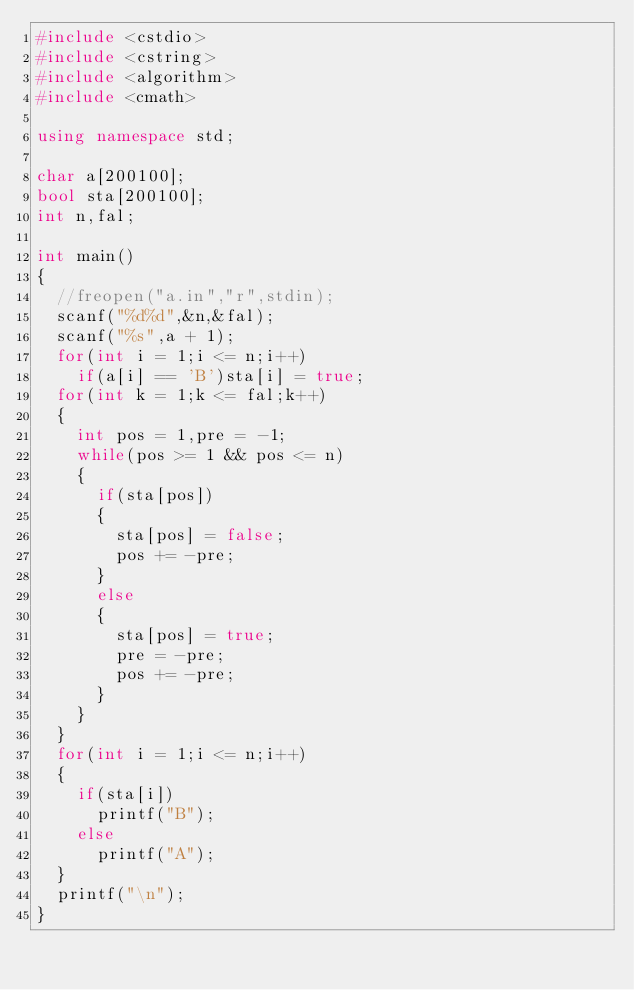Convert code to text. <code><loc_0><loc_0><loc_500><loc_500><_C++_>#include <cstdio>
#include <cstring>
#include <algorithm>
#include <cmath> 

using namespace std;

char a[200100];
bool sta[200100];
int n,fal;

int main()
{
	//freopen("a.in","r",stdin);
	scanf("%d%d",&n,&fal);
	scanf("%s",a + 1);
	for(int i = 1;i <= n;i++)
		if(a[i] == 'B')sta[i] = true;
	for(int k = 1;k <= fal;k++)
	{
		int pos = 1,pre = -1;
		while(pos >= 1 && pos <= n)
		{
			if(sta[pos])
			{
				sta[pos] = false;
				pos += -pre;
			}
			else
			{
				sta[pos] = true;
				pre = -pre;
				pos += -pre;
			}
		}
	}
	for(int i = 1;i <= n;i++)
	{
		if(sta[i])
			printf("B");
		else
			printf("A");
	}
	printf("\n");
}</code> 